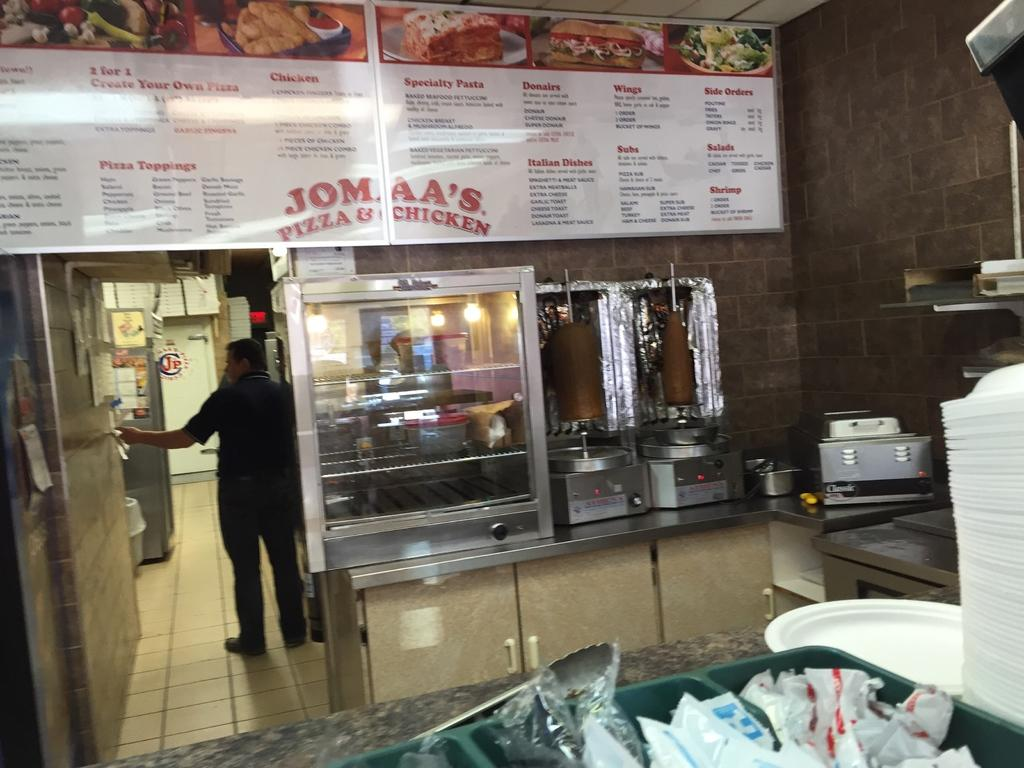Provide a one-sentence caption for the provided image. Man working in a restaurant named Jomaa's Pizza & Chicken. 